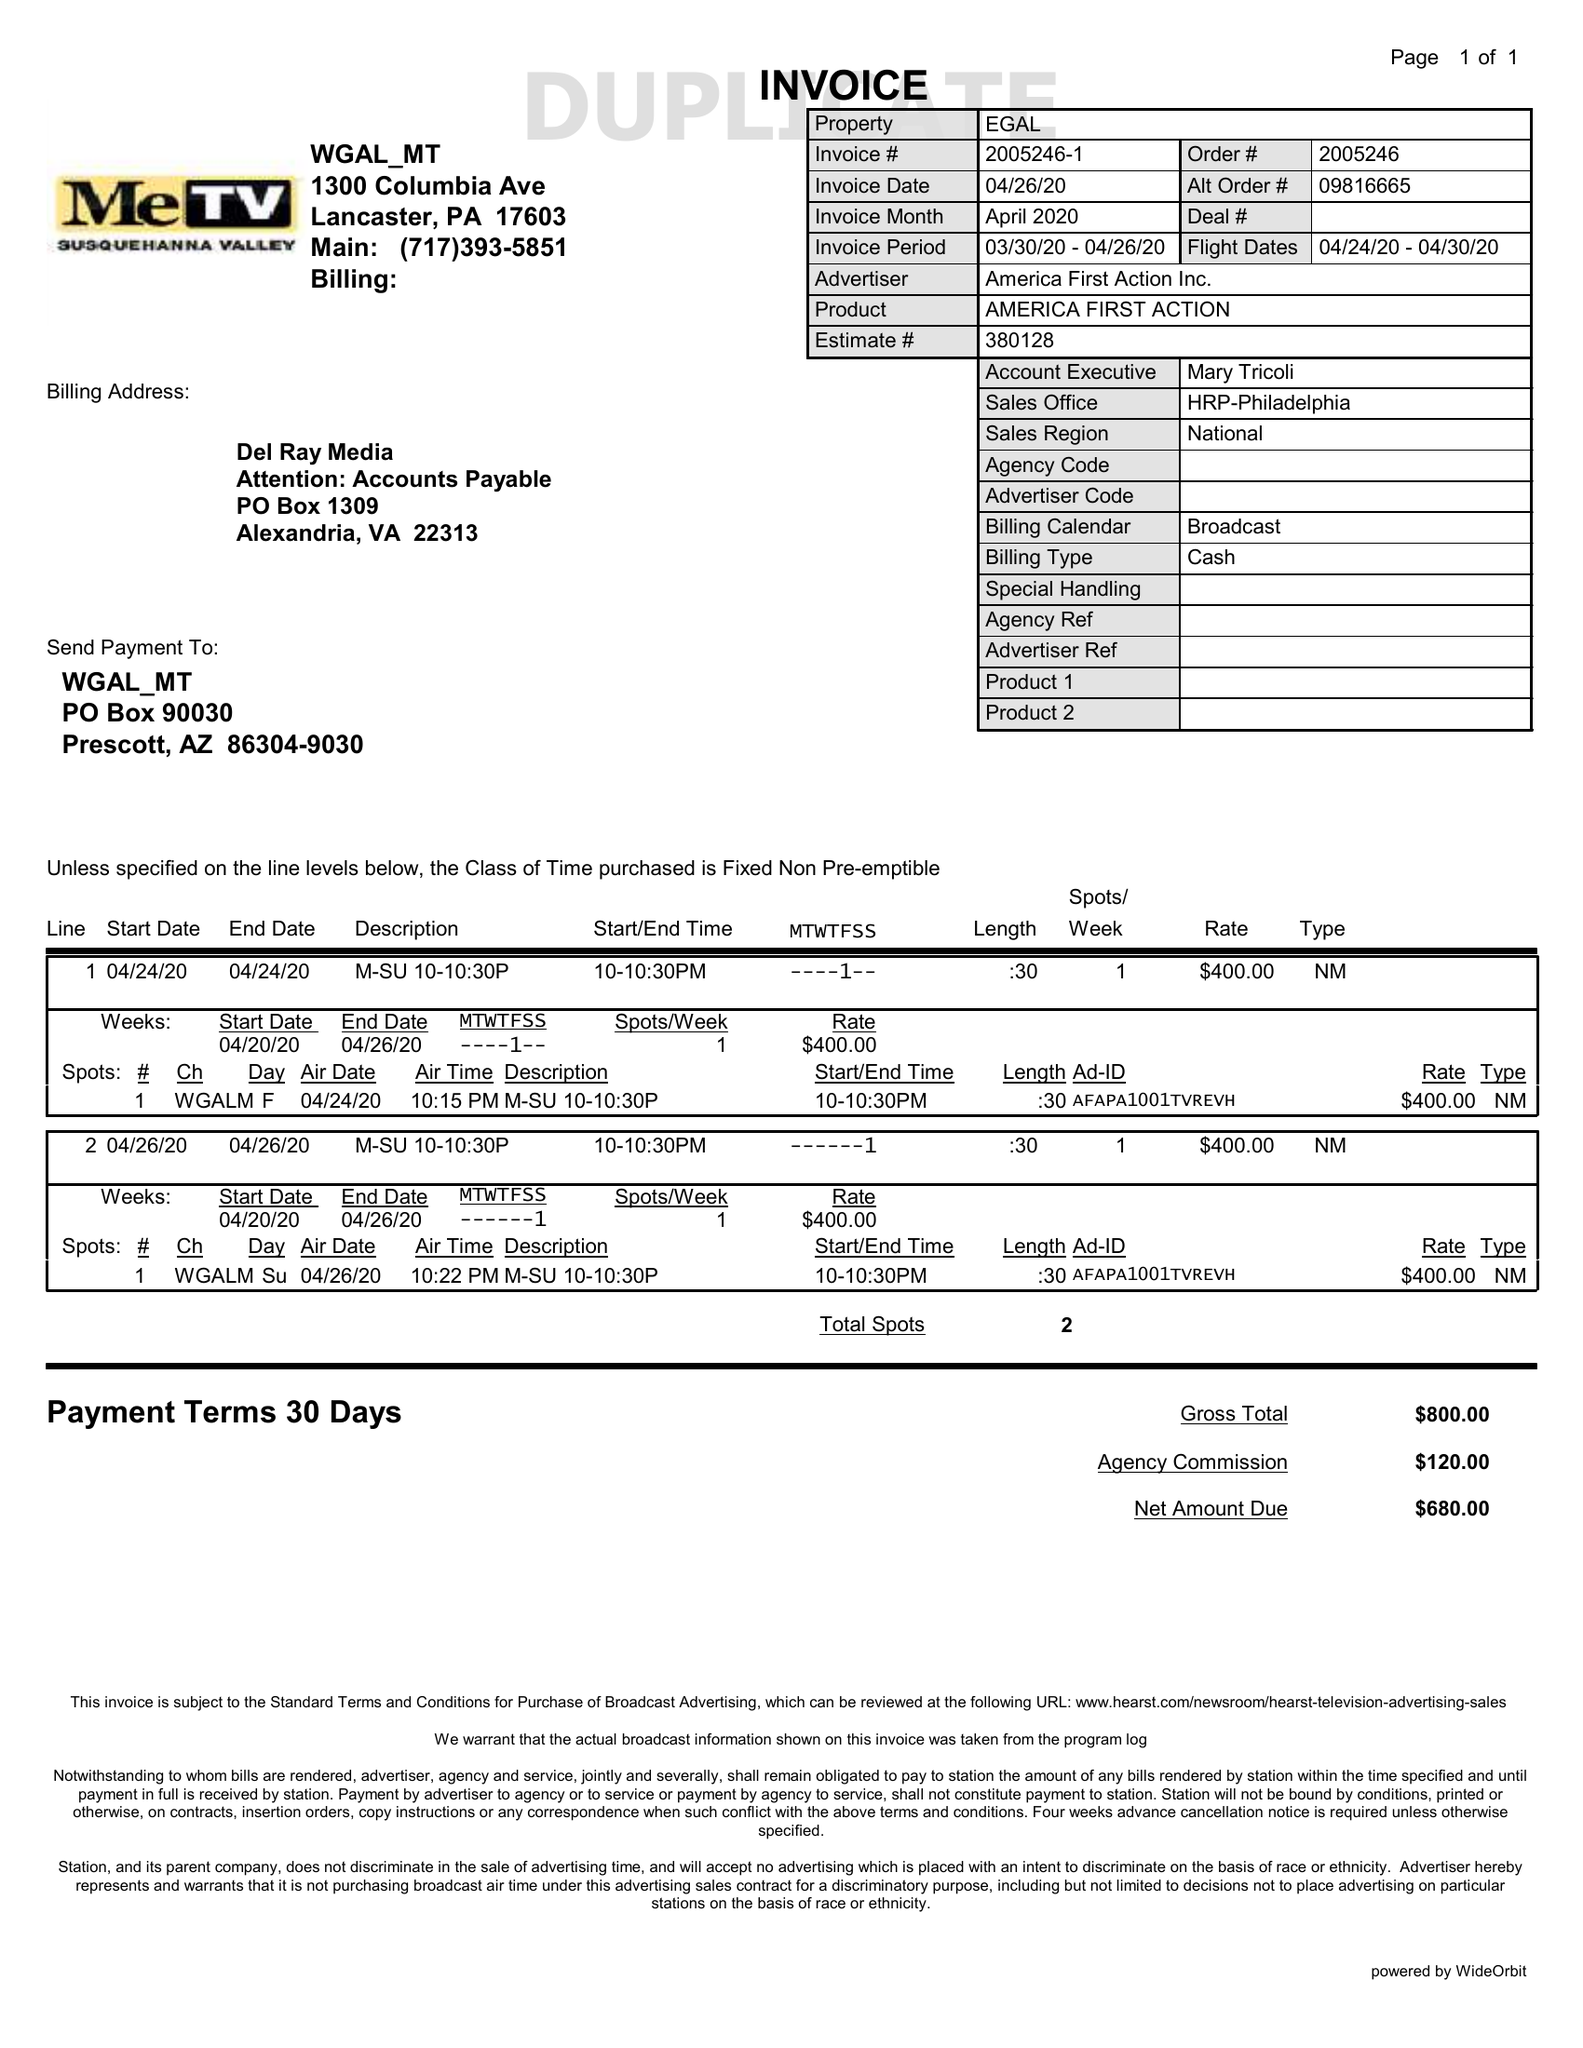What is the value for the gross_amount?
Answer the question using a single word or phrase. 800.00 